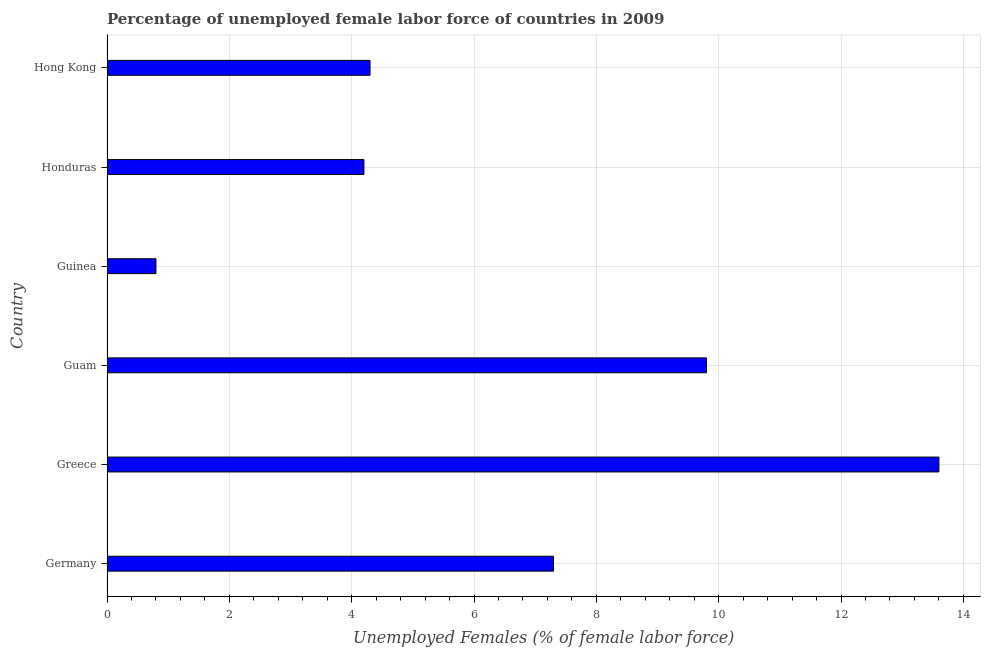Does the graph contain grids?
Offer a terse response. Yes. What is the title of the graph?
Provide a succinct answer. Percentage of unemployed female labor force of countries in 2009. What is the label or title of the X-axis?
Offer a terse response. Unemployed Females (% of female labor force). What is the total unemployed female labour force in Honduras?
Your response must be concise. 4.2. Across all countries, what is the maximum total unemployed female labour force?
Offer a very short reply. 13.6. Across all countries, what is the minimum total unemployed female labour force?
Offer a very short reply. 0.8. In which country was the total unemployed female labour force minimum?
Offer a very short reply. Guinea. What is the sum of the total unemployed female labour force?
Offer a terse response. 40. What is the average total unemployed female labour force per country?
Make the answer very short. 6.67. What is the median total unemployed female labour force?
Provide a succinct answer. 5.8. What is the ratio of the total unemployed female labour force in Germany to that in Greece?
Offer a very short reply. 0.54. Is the total unemployed female labour force in Germany less than that in Greece?
Provide a succinct answer. Yes. What is the difference between the highest and the second highest total unemployed female labour force?
Ensure brevity in your answer.  3.8. In how many countries, is the total unemployed female labour force greater than the average total unemployed female labour force taken over all countries?
Offer a very short reply. 3. What is the difference between two consecutive major ticks on the X-axis?
Your answer should be compact. 2. What is the Unemployed Females (% of female labor force) of Germany?
Provide a short and direct response. 7.3. What is the Unemployed Females (% of female labor force) in Greece?
Keep it short and to the point. 13.6. What is the Unemployed Females (% of female labor force) in Guam?
Your answer should be compact. 9.8. What is the Unemployed Females (% of female labor force) of Guinea?
Offer a terse response. 0.8. What is the Unemployed Females (% of female labor force) in Honduras?
Offer a very short reply. 4.2. What is the Unemployed Females (% of female labor force) in Hong Kong?
Make the answer very short. 4.3. What is the difference between the Unemployed Females (% of female labor force) in Germany and Greece?
Your answer should be very brief. -6.3. What is the difference between the Unemployed Females (% of female labor force) in Germany and Hong Kong?
Offer a very short reply. 3. What is the difference between the Unemployed Females (% of female labor force) in Greece and Guam?
Make the answer very short. 3.8. What is the difference between the Unemployed Females (% of female labor force) in Greece and Honduras?
Give a very brief answer. 9.4. What is the difference between the Unemployed Females (% of female labor force) in Guam and Guinea?
Your answer should be compact. 9. What is the difference between the Unemployed Females (% of female labor force) in Guam and Honduras?
Ensure brevity in your answer.  5.6. What is the difference between the Unemployed Females (% of female labor force) in Guam and Hong Kong?
Offer a very short reply. 5.5. What is the difference between the Unemployed Females (% of female labor force) in Honduras and Hong Kong?
Offer a terse response. -0.1. What is the ratio of the Unemployed Females (% of female labor force) in Germany to that in Greece?
Give a very brief answer. 0.54. What is the ratio of the Unemployed Females (% of female labor force) in Germany to that in Guam?
Provide a succinct answer. 0.74. What is the ratio of the Unemployed Females (% of female labor force) in Germany to that in Guinea?
Ensure brevity in your answer.  9.12. What is the ratio of the Unemployed Females (% of female labor force) in Germany to that in Honduras?
Your answer should be very brief. 1.74. What is the ratio of the Unemployed Females (% of female labor force) in Germany to that in Hong Kong?
Your response must be concise. 1.7. What is the ratio of the Unemployed Females (% of female labor force) in Greece to that in Guam?
Your answer should be compact. 1.39. What is the ratio of the Unemployed Females (% of female labor force) in Greece to that in Honduras?
Give a very brief answer. 3.24. What is the ratio of the Unemployed Females (% of female labor force) in Greece to that in Hong Kong?
Ensure brevity in your answer.  3.16. What is the ratio of the Unemployed Females (% of female labor force) in Guam to that in Guinea?
Keep it short and to the point. 12.25. What is the ratio of the Unemployed Females (% of female labor force) in Guam to that in Honduras?
Give a very brief answer. 2.33. What is the ratio of the Unemployed Females (% of female labor force) in Guam to that in Hong Kong?
Ensure brevity in your answer.  2.28. What is the ratio of the Unemployed Females (% of female labor force) in Guinea to that in Honduras?
Offer a terse response. 0.19. What is the ratio of the Unemployed Females (% of female labor force) in Guinea to that in Hong Kong?
Give a very brief answer. 0.19. What is the ratio of the Unemployed Females (% of female labor force) in Honduras to that in Hong Kong?
Your response must be concise. 0.98. 